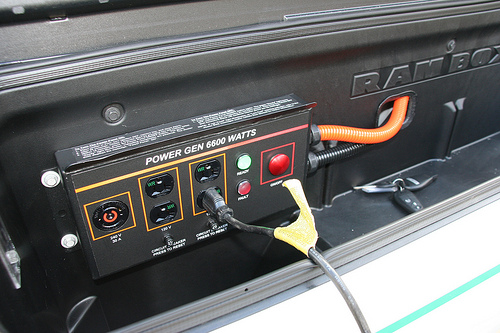<image>
Is the plug in the outlet? No. The plug is not contained within the outlet. These objects have a different spatial relationship. 